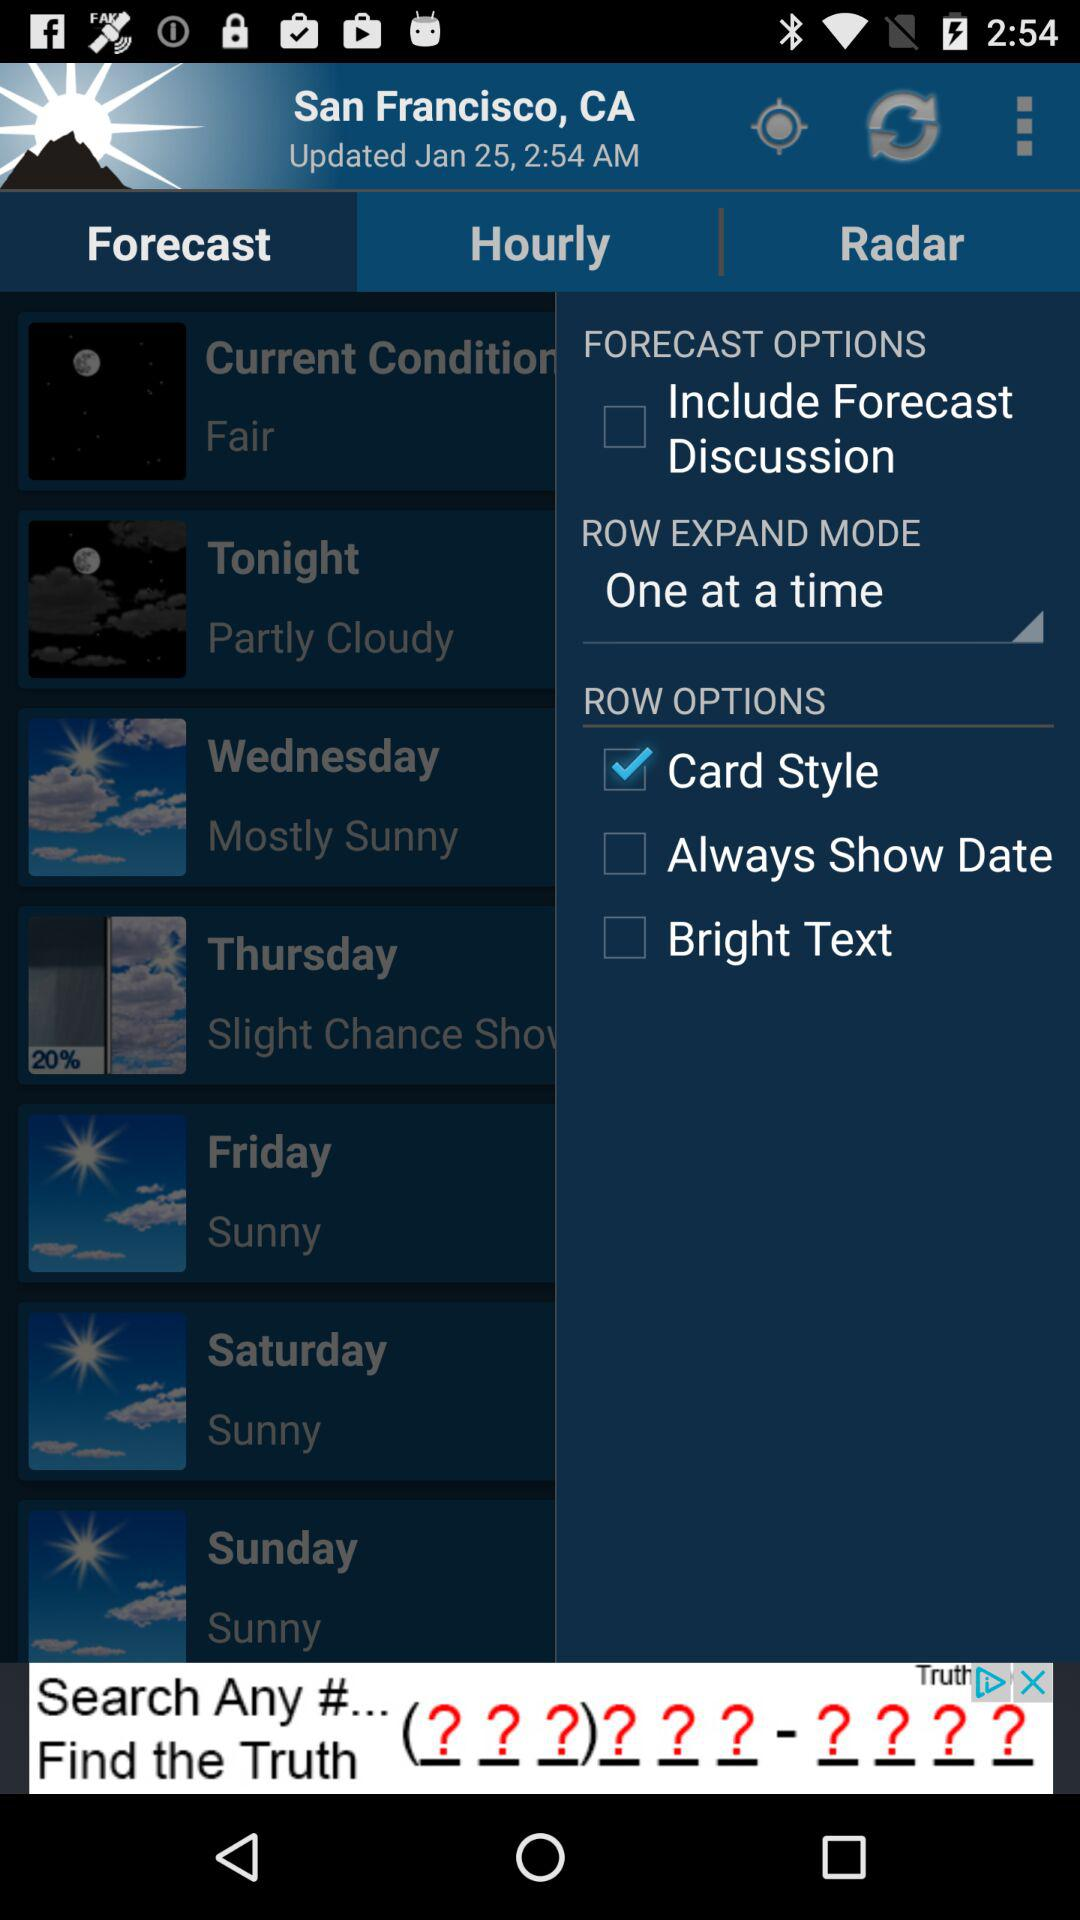Which is the selected row option? The selected row option is "Card Style". 